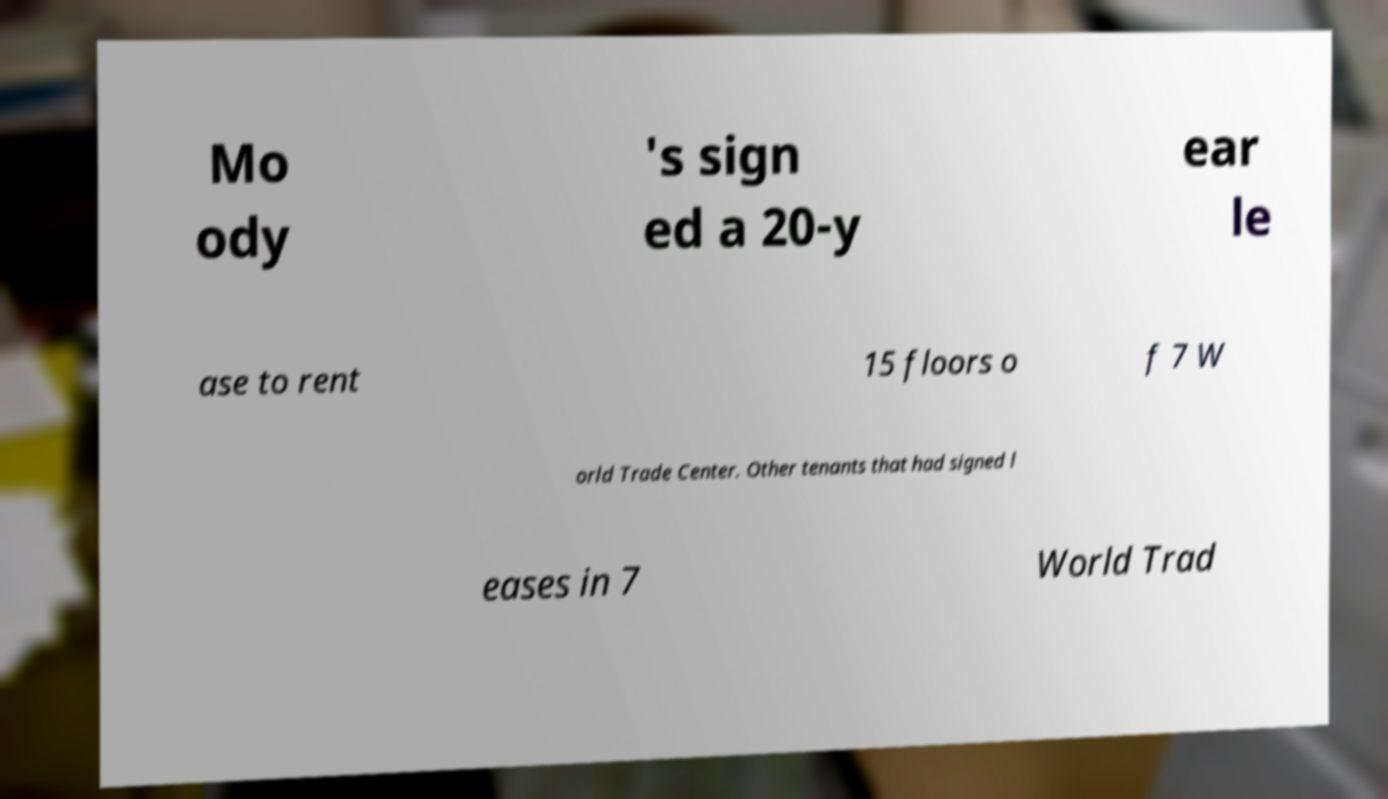I need the written content from this picture converted into text. Can you do that? Mo ody 's sign ed a 20-y ear le ase to rent 15 floors o f 7 W orld Trade Center. Other tenants that had signed l eases in 7 World Trad 